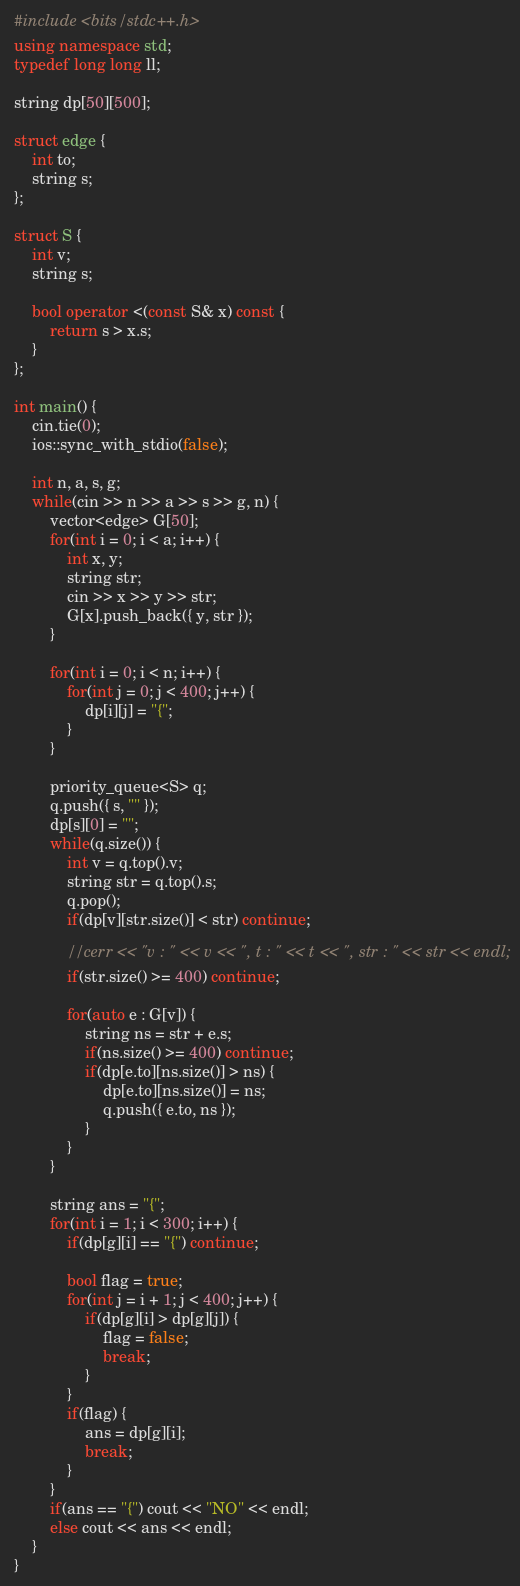Convert code to text. <code><loc_0><loc_0><loc_500><loc_500><_C++_>#include <bits/stdc++.h>
using namespace std;
typedef long long ll;

string dp[50][500];

struct edge {
	int to;
	string s;
};

struct S {
	int v;
	string s;

	bool operator <(const S& x) const {
		return s > x.s;
	}
};

int main() {
	cin.tie(0);
	ios::sync_with_stdio(false);

	int n, a, s, g;
	while(cin >> n >> a >> s >> g, n) {
		vector<edge> G[50];
		for(int i = 0; i < a; i++) {
			int x, y;
			string str;
			cin >> x >> y >> str;
			G[x].push_back({ y, str });
		}

		for(int i = 0; i < n; i++) {
			for(int j = 0; j < 400; j++) {
				dp[i][j] = "{";
			}
		}

		priority_queue<S> q;
		q.push({ s, "" });
		dp[s][0] = "";
		while(q.size()) {
			int v = q.top().v;
			string str = q.top().s;
			q.pop();
			if(dp[v][str.size()] < str) continue;

			//cerr << "v : " << v << ", t : " << t << ", str : " << str << endl;
			if(str.size() >= 400) continue;

			for(auto e : G[v]) {
				string ns = str + e.s;
				if(ns.size() >= 400) continue;
				if(dp[e.to][ns.size()] > ns) {
					dp[e.to][ns.size()] = ns;
					q.push({ e.to, ns });
				}
			}
		}

		string ans = "{";
		for(int i = 1; i < 300; i++) {
			if(dp[g][i] == "{") continue;

			bool flag = true;
			for(int j = i + 1; j < 400; j++) {
				if(dp[g][i] > dp[g][j]) {
					flag = false;
					break;
				}
			}
			if(flag) {
				ans = dp[g][i];
				break;
			}
		}
		if(ans == "{") cout << "NO" << endl;
		else cout << ans << endl;
	}
}</code> 